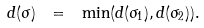Convert formula to latex. <formula><loc_0><loc_0><loc_500><loc_500>d ( \sigma ) \ = \ \min ( d ( \sigma _ { 1 } ) , d ( \sigma _ { 2 } ) ) .</formula> 